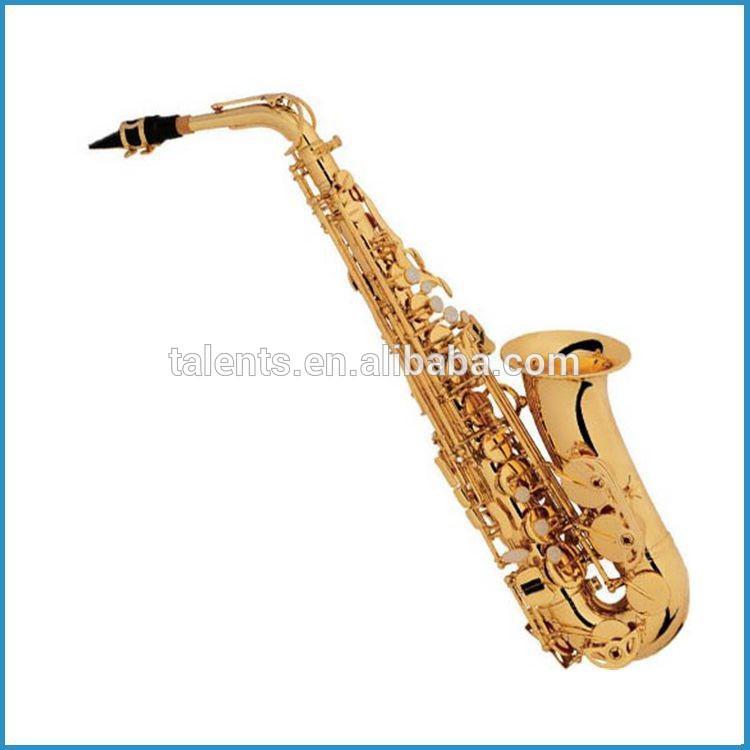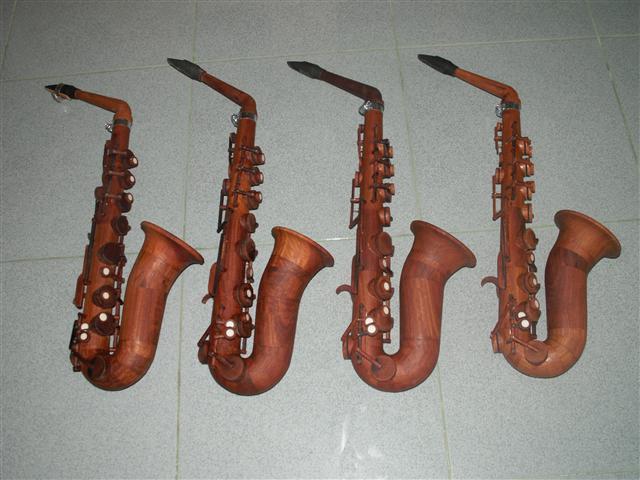The first image is the image on the left, the second image is the image on the right. For the images displayed, is the sentence "One image contains three or more saxophones." factually correct? Answer yes or no. Yes. 